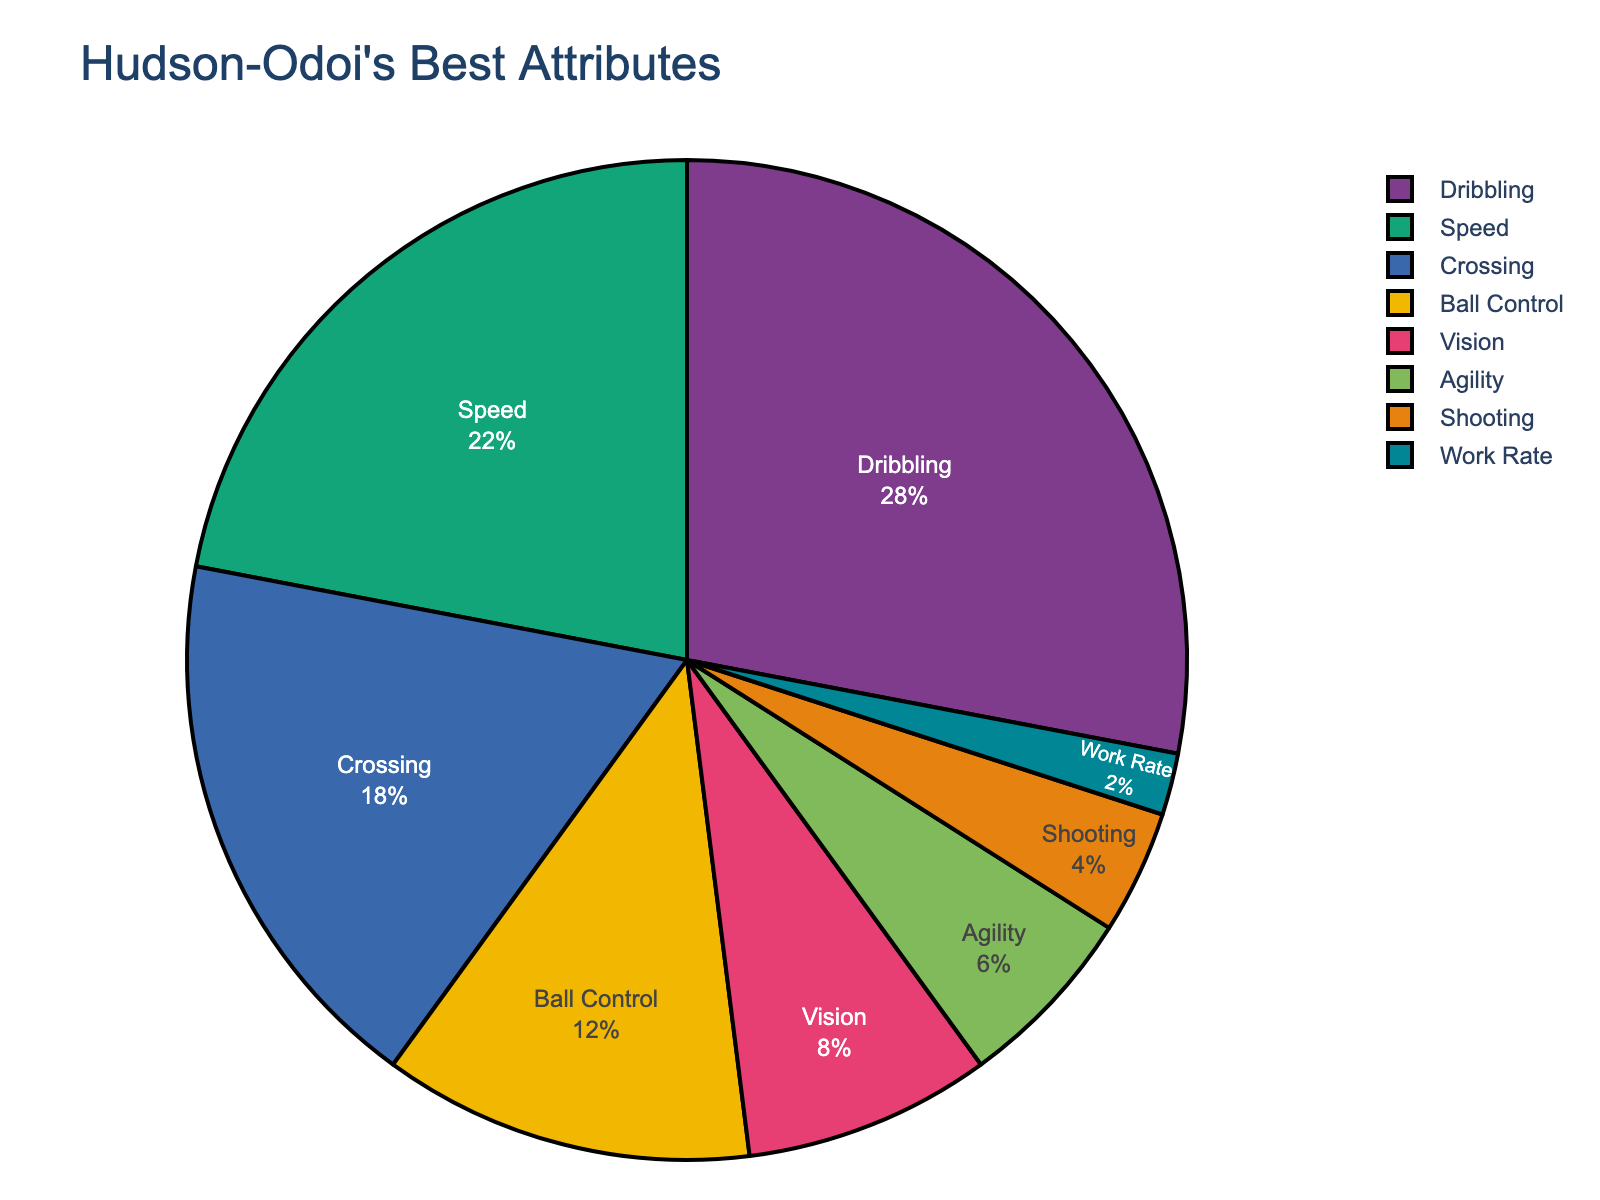What is Hudson-Odoi's most highly rated attribute according to the pie chart? By looking at the pie chart, Hudson-Odoi's most highly rated attribute is the segment with the largest percentage. The largest segment is labeled "Dribbling" at 28%.
Answer: Dribbling What percentage of fans consider Ball Control and Vision together as Hudson-Odoi's best attributes? Add the percentages for Ball Control and Vision. Ball Control has 12% and Vision has 8%, so 12% + 8% = 20%.
Answer: 20% Which attribute has a higher rating, Shooting or Work Rate, and by how much? Compare the percentages of Shooting and Work Rate. Shooting has 4% and Work Rate has 2%. The difference is 4% - 2% = 2%.
Answer: Shooting by 2% What is the combined percentage of fans who consider Speed and Crossing as Hudson-Odoi's best attributes? Add the percentages for Speed and Crossing. Speed has 22% and Crossing has 18%, so 22% + 18% = 40%.
Answer: 40% Rank the attributes from highest to lowest based on fan perception. List the attributes in descending order based on their percentages: Dribbling (28%), Speed (22%), Crossing (18%), Ball Control (12%), Vision (8%), Agility (6%), Shooting (4%), Work Rate (2%).
Answer: Dribbling, Speed, Crossing, Ball Control, Vision, Agility, Shooting, Work Rate What is the difference in percentage points between the highest-rated attribute and the lowest-rated attribute? Subtract the percentage of the lowest-rated attribute (Work Rate - 2%) from the highest-rated attribute (Dribbling - 28%). 28% - 2% = 26%.
Answer: 26% Which attributes together make up more than half of the total fan perception and what is their combined percentage? The combined percentage must exceed 50%. The top three attributes are Dribbling (28%), Speed (22%), and Crossing (18%). Adding these gives 28% + 22% + 18% = 68%, which is more than half.
Answer: Dribbling, Speed, and Crossing; 68% What is the average percentage rating of Ball Control, Vision, and Agility? Calculate the average by adding the percentages for Ball Control (12%), Vision (8%), and Agility (6%), then dividing by 3. (12% + 8% + 6%) / 3 = 26% / 3 ≈ 8.67%.
Answer: 8.67% Is the percentage of fans who favor Hudson-Odoi's Dribbling skill greater than the combined percentage of those who favor his Shooting and Work Rate? First, calculate the combined percentage of Shooting and Work Rate which is 4% + 2% = 6%. Now check if Dribbling (28%) is greater than 6%, which it is.
Answer: Yes 